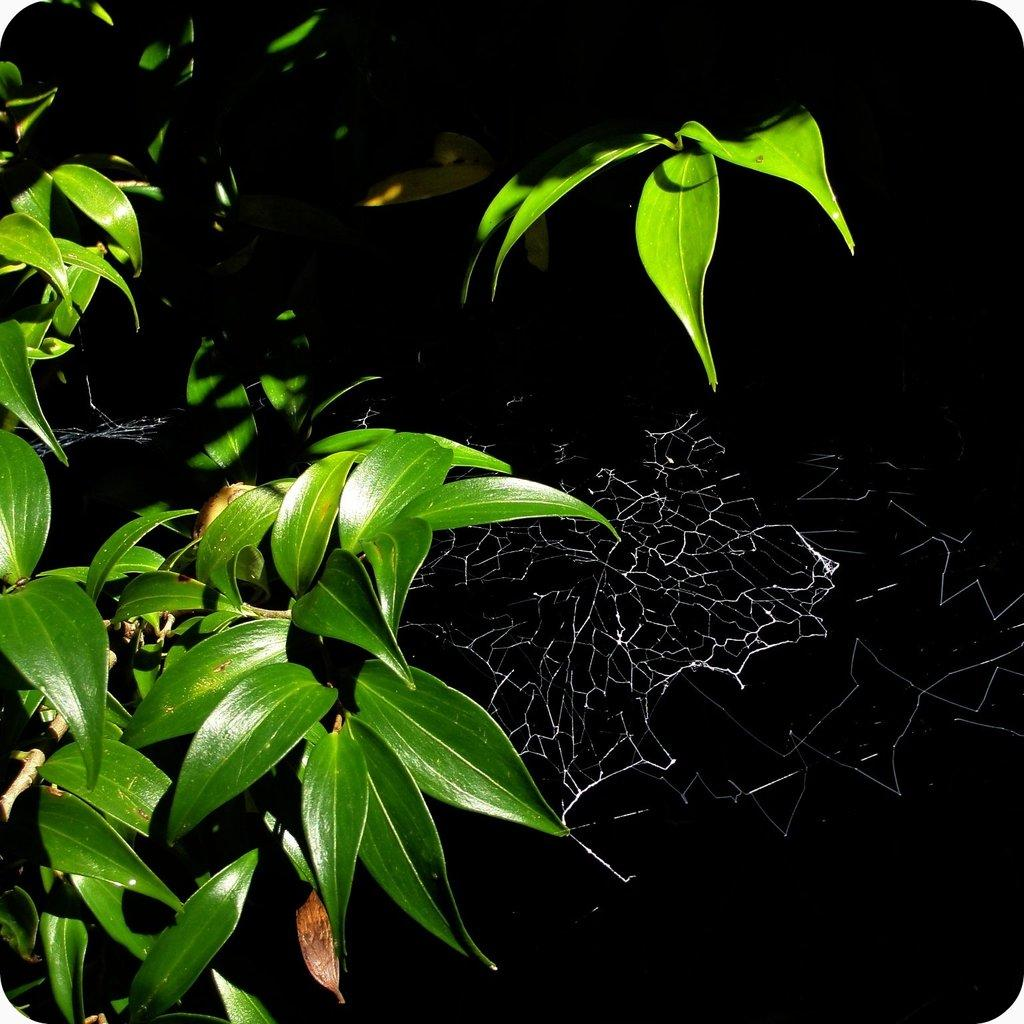What type of natural elements can be seen in the image? There are leaves in the image. What man-made structure can be seen in the image? There is a spider web in the image. What type of design is featured on the chessboard in the image? There is no chessboard present in the image; it only contains leaves and a spider web. 